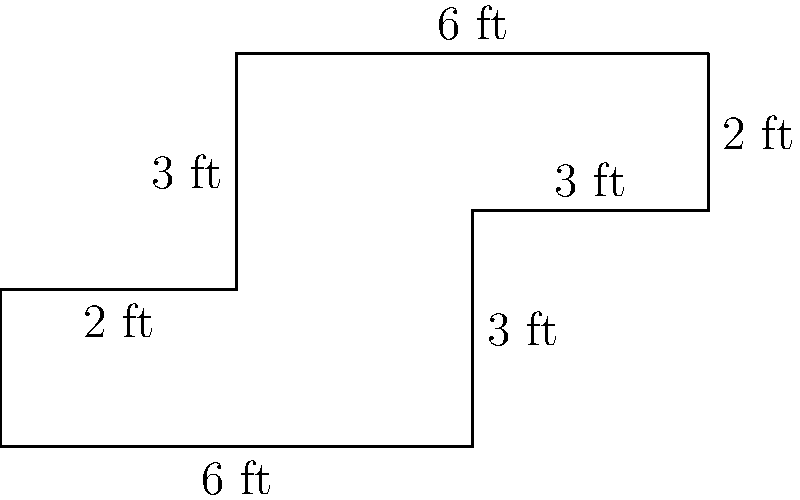As a childproofing expert, you're designing a custom playpen with an irregular shape to fit a specific room layout. The playpen's dimensions are shown in the diagram. Calculate the perimeter of this playpen to determine how much protective padding you'll need to cover its edges. To calculate the perimeter of the playpen, we need to add up the lengths of all sides:

1. Bottom side: 6 ft
2. Right side (bottom part): 3 ft
3. Small right extension: 3 ft
4. Top right side: 2 ft
5. Top side: 6 ft
6. Left side (top part): 3 ft
7. Small left indentation: 2 ft

Adding these lengths:

$$\text{Perimeter} = 6 + 3 + 3 + 2 + 6 + 3 + 2 = 25\text{ ft}$$

Therefore, the total perimeter of the playpen is 25 feet.
Answer: 25 feet 